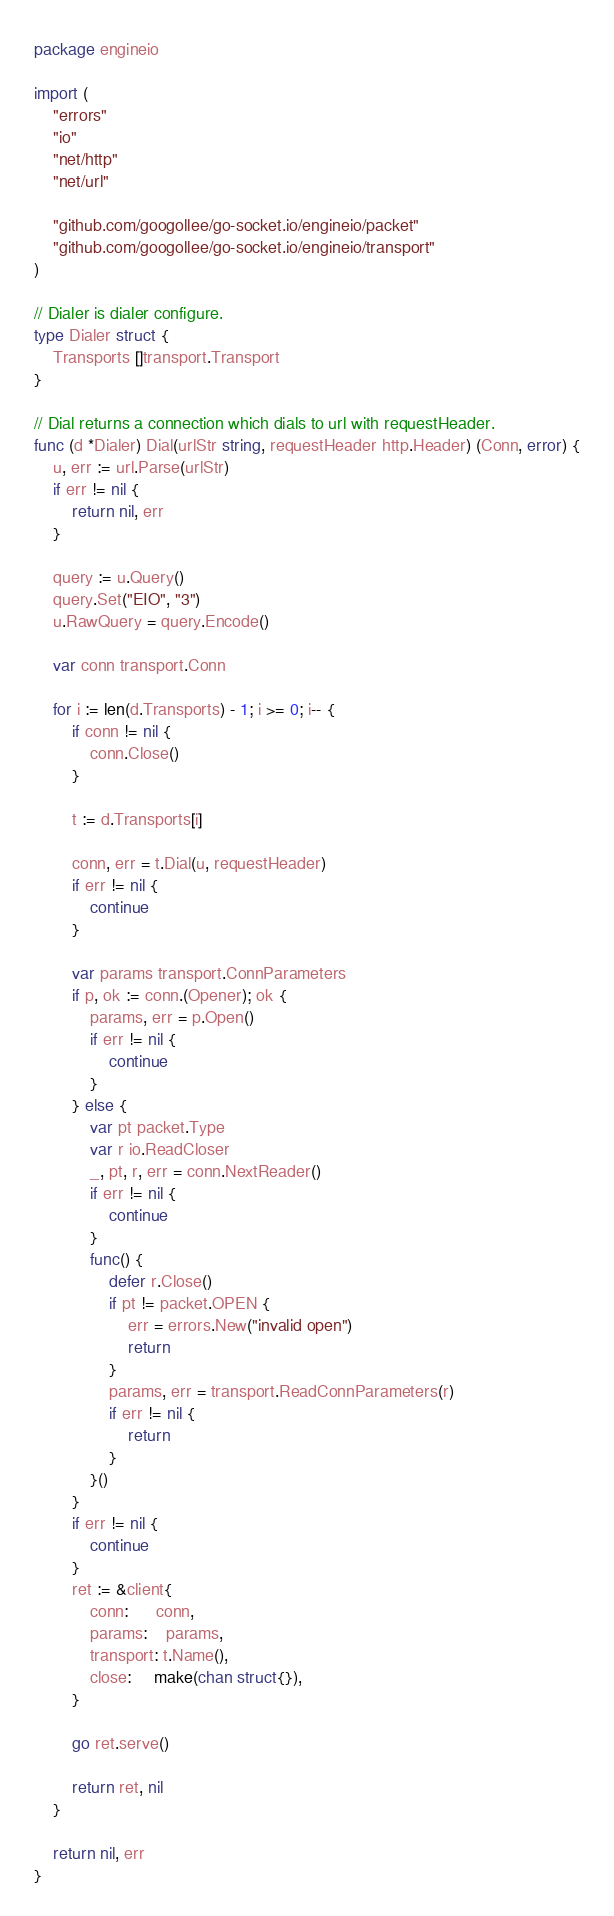<code> <loc_0><loc_0><loc_500><loc_500><_Go_>package engineio

import (
	"errors"
	"io"
	"net/http"
	"net/url"

	"github.com/googollee/go-socket.io/engineio/packet"
	"github.com/googollee/go-socket.io/engineio/transport"
)

// Dialer is dialer configure.
type Dialer struct {
	Transports []transport.Transport
}

// Dial returns a connection which dials to url with requestHeader.
func (d *Dialer) Dial(urlStr string, requestHeader http.Header) (Conn, error) {
	u, err := url.Parse(urlStr)
	if err != nil {
		return nil, err
	}

	query := u.Query()
	query.Set("EIO", "3")
	u.RawQuery = query.Encode()

	var conn transport.Conn

	for i := len(d.Transports) - 1; i >= 0; i-- {
		if conn != nil {
			conn.Close()
		}

		t := d.Transports[i]

		conn, err = t.Dial(u, requestHeader)
		if err != nil {
			continue
		}

		var params transport.ConnParameters
		if p, ok := conn.(Opener); ok {
			params, err = p.Open()
			if err != nil {
				continue
			}
		} else {
			var pt packet.Type
			var r io.ReadCloser
			_, pt, r, err = conn.NextReader()
			if err != nil {
				continue
			}
			func() {
				defer r.Close()
				if pt != packet.OPEN {
					err = errors.New("invalid open")
					return
				}
				params, err = transport.ReadConnParameters(r)
				if err != nil {
					return
				}
			}()
		}
		if err != nil {
			continue
		}
		ret := &client{
			conn:      conn,
			params:    params,
			transport: t.Name(),
			close:     make(chan struct{}),
		}

		go ret.serve()

		return ret, nil
	}

	return nil, err
}
</code> 